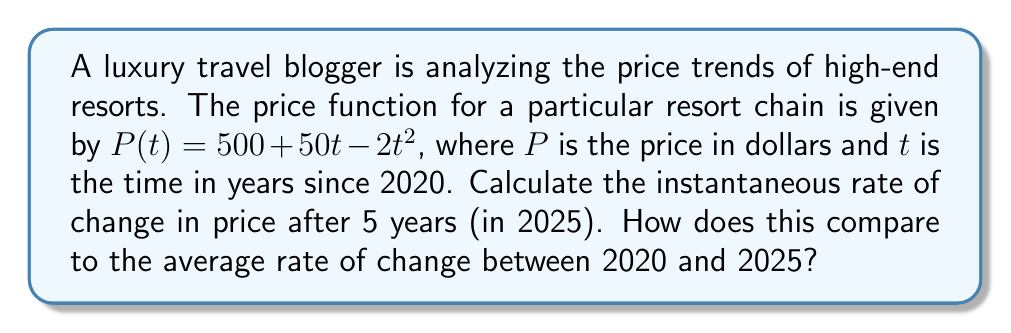Teach me how to tackle this problem. 1. To find the instantaneous rate of change, we need to calculate the derivative of the price function:
   $$\frac{dP}{dt} = 50 - 4t$$

2. Evaluate the derivative at $t = 5$ to find the instantaneous rate of change in 2025:
   $$\frac{dP}{dt}\bigg|_{t=5} = 50 - 4(5) = 50 - 20 = 30$$

3. To calculate the average rate of change between 2020 and 2025:
   a. Calculate $P(0)$ (price in 2020):
      $$P(0) = 500 + 50(0) - 2(0)^2 = 500$$
   b. Calculate $P(5)$ (price in 2025):
      $$P(5) = 500 + 50(5) - 2(5)^2 = 500 + 250 - 50 = 700$$
   c. Use the average rate of change formula:
      $$\text{Average rate of change} = \frac{P(5) - P(0)}{5-0} = \frac{700 - 500}{5} = \frac{200}{5} = 40$$

4. Compare the instantaneous rate (30 dollars/year) to the average rate (40 dollars/year).
Answer: Instantaneous rate: $30 \frac{\text{dollars}}{\text{year}}$; Average rate: $40 \frac{\text{dollars}}{\text{year}}$ 